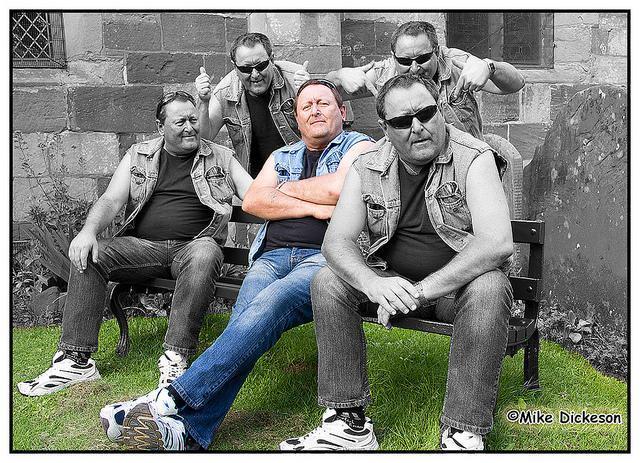How many images of the man are black and white?
Give a very brief answer. 4. How many men in the picture are wearing sunglasses?
Give a very brief answer. 3. How many people are there?
Give a very brief answer. 5. 